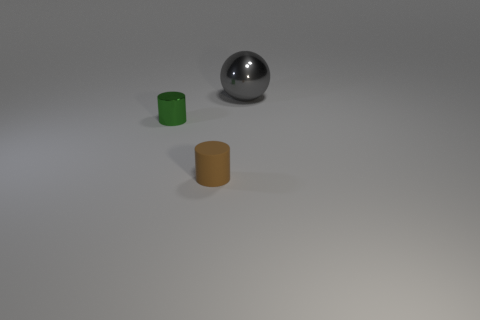Is the number of tiny yellow metallic things less than the number of balls?
Make the answer very short. Yes. Does the sphere have the same material as the tiny green cylinder?
Ensure brevity in your answer.  Yes. There is a metal thing that is in front of the gray sphere; is its color the same as the matte cylinder?
Ensure brevity in your answer.  No. There is a thing right of the rubber object; what number of small green things are in front of it?
Your response must be concise. 1. There is another cylinder that is the same size as the matte cylinder; what is its color?
Your response must be concise. Green. There is a small object on the right side of the tiny green metal cylinder; what material is it?
Keep it short and to the point. Rubber. The thing that is both to the left of the gray ball and right of the tiny metal object is made of what material?
Your answer should be compact. Rubber. There is a metallic object on the left side of the gray ball; is it the same size as the rubber object?
Provide a short and direct response. Yes. The tiny matte object has what shape?
Give a very brief answer. Cylinder. What number of other large gray metallic objects are the same shape as the gray metallic thing?
Ensure brevity in your answer.  0. 